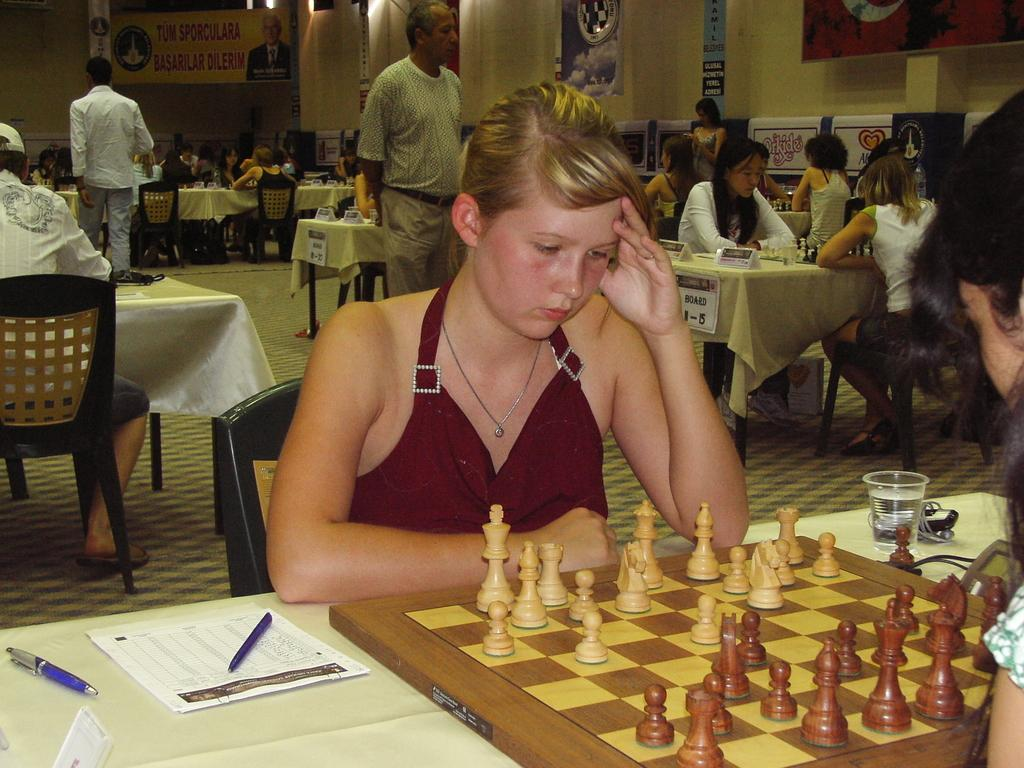What are the people in the image doing? People are sitting on chairs near a table. What is on the table in the image? There is a chess board, a bottle, a glass, a pen, and paper on the table. What can be seen on the wall in the image? There is a poster on the wall. Where is the bear sitting in the image? There is no bear present in the image. What color is the kite flying outside the window in the image? There is no kite or window visible in the image. 